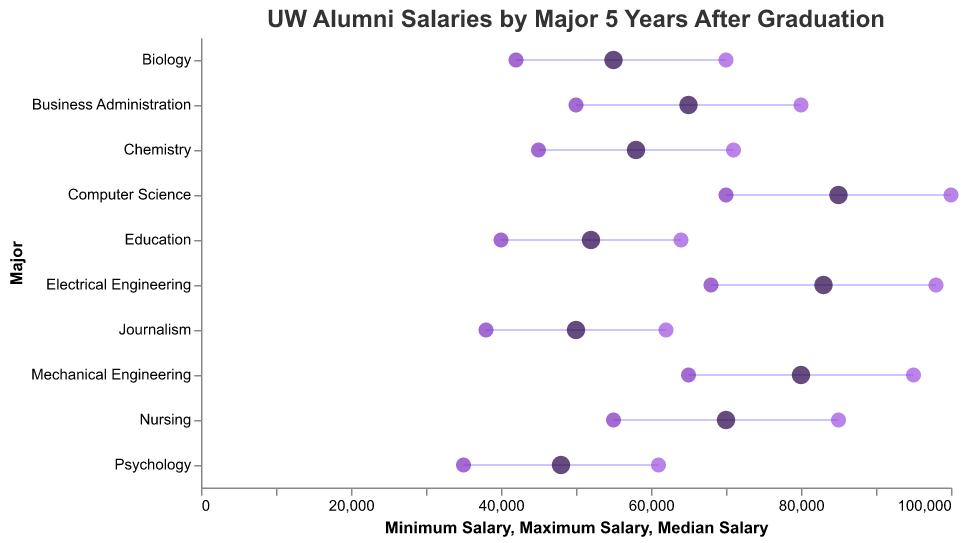What is the title of the plot? The plot's title is usually displayed at the top. It provides an overview of what the plot represents, showing "UW Alumni Salaries by Major 5 Years After Graduation".
Answer: UW Alumni Salaries by Major 5 Years After Graduation How are the Minimum and Maximum Salaries visually indicated in the plot? In a dumbbell plot, the Minimum and Maximum Salaries are connected by a line (or rule). The Minimum Salary is marked by a point on the left (color: #7b2cbf), and the Maximum Salary is marked by a point on the right (color: #9d4edd).
Answer: A rule connects the Minimum and Maximum Salaries, with points at each end Which major has the highest median salary? The median salary is indicated by the largest point in the middle of the dumbbell. By looking across the majors, we can see that Computer Science has the point furthest to the right for the median value.
Answer: Computer Science What is the range of salaries for Nursing? The range of salaries is given by subtracting the Minimum Salary from the Maximum Salary. For Nursing, the Minimum Salary is 55,000, and the Maximum Salary is 85,000. The range is thus 85,000 - 55,000.
Answer: 30,000 Which majors have overlapping salary ranges? Overlapping ranges mean that the interquartile ranges (the lines connecting minimum and maximum salaries) intersect visually. By scanning visually, we can see overlaps between majors like Business Administration and Nursing and between Electrical Engineering and Mechanical Engineering.
Answer: Business Administration and Nursing; Electrical Engineering and Mechanical Engineering What is the median salary of Chemistry? The median salary for Chemistry is represented by the largest point in the line connecting minimum and maximum salaries for that major. It is positioned at 58,000.
Answer: 58,000 Between Mechanical Engineering and Electrical Engineering, which has a higher minimum salary? For a comparison of minimum salaries, we look at the leftmost points of both dumbbells. Electrical Engineering's point is at 68,000, whereas Mechanical Engineering's point is at 65,000.
Answer: Electrical Engineering By how much does the maximum salary of Computer Science exceed that of Business Administration? The maximum salary for Computer Science is 100,000, while for Business Administration, it is 80,000. Subtract the Maximum Salary of Business Administration from that of Computer Science (100,000 - 80,000).
Answer: 20,000 What is the median salary difference between Education and Psychology? The median salary for Education is 52,000, and for Psychology, it is 48,000. Subtract to find the difference (52,000 - 48,000).
Answer: 4,000 Which field has the smallest range of salaries and what is that range? To find the smallest range, calculate the range for each field by subtracting the Minimum Salary from the Maximum Salary and compare them. The smallest range is for Chemistry (71,000 - 45,000).
Answer: Chemistry, 26,000 